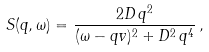Convert formula to latex. <formula><loc_0><loc_0><loc_500><loc_500>S ( q , \omega ) = \frac { 2 D \, q ^ { 2 } } { ( \omega - q v ) ^ { 2 } + D ^ { 2 } \, q ^ { 4 } } \, ,</formula> 